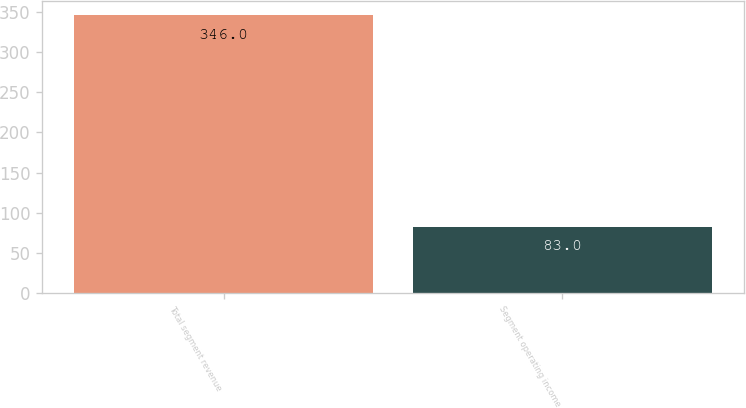Convert chart. <chart><loc_0><loc_0><loc_500><loc_500><bar_chart><fcel>Total segment revenue<fcel>Segment operating income<nl><fcel>346<fcel>83<nl></chart> 